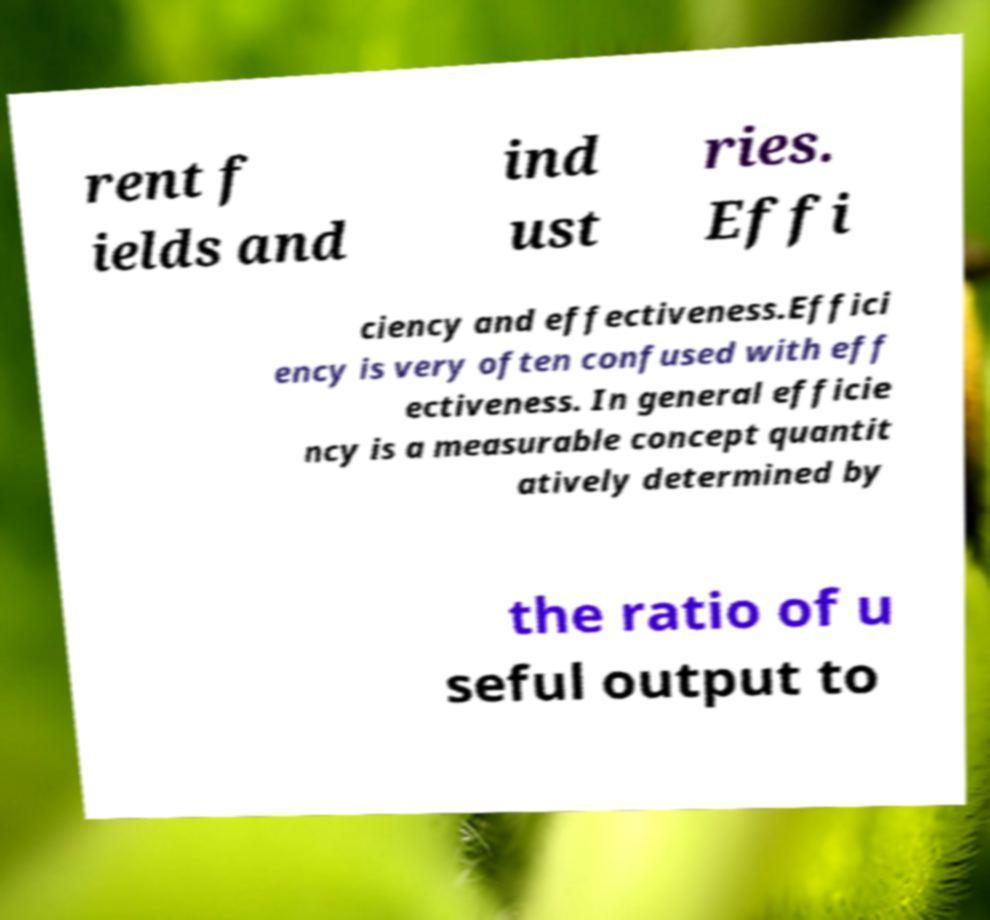Please read and relay the text visible in this image. What does it say? rent f ields and ind ust ries. Effi ciency and effectiveness.Effici ency is very often confused with eff ectiveness. In general efficie ncy is a measurable concept quantit atively determined by the ratio of u seful output to 